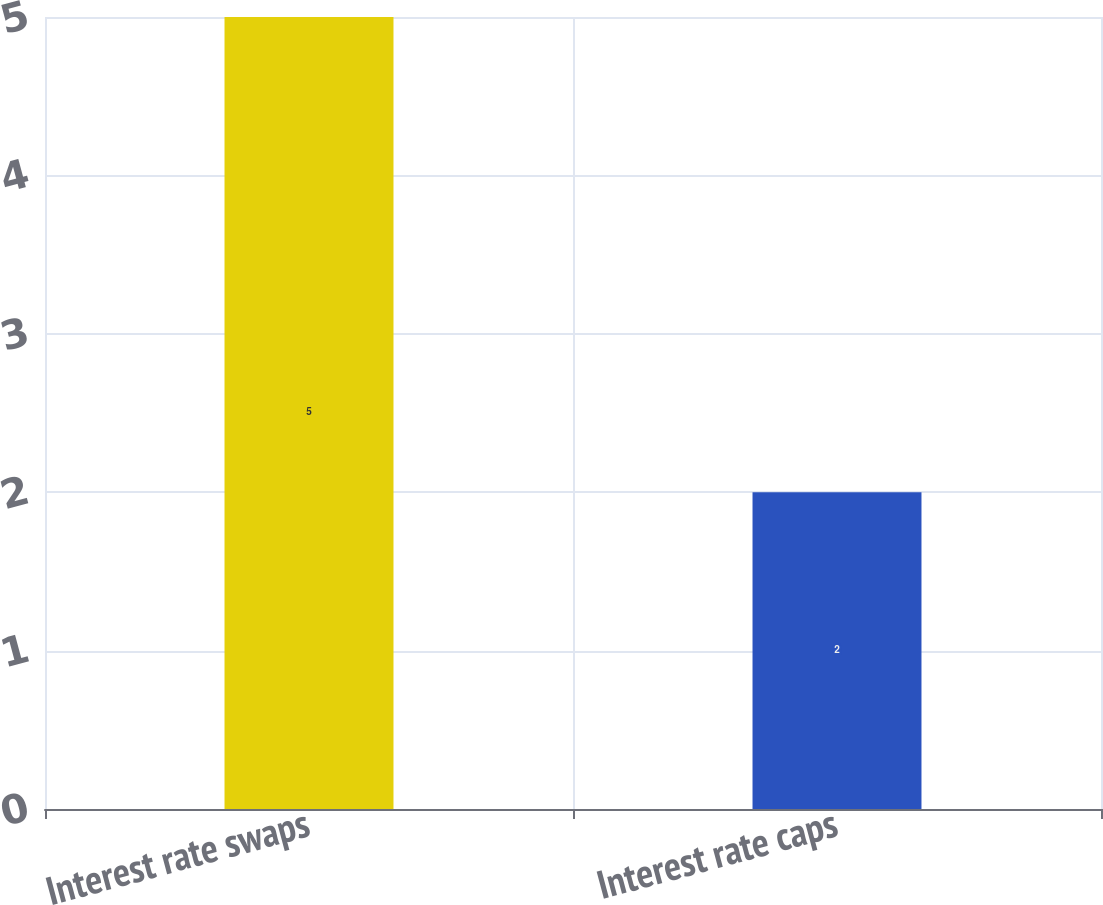Convert chart to OTSL. <chart><loc_0><loc_0><loc_500><loc_500><bar_chart><fcel>Interest rate swaps<fcel>Interest rate caps<nl><fcel>5<fcel>2<nl></chart> 